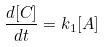<formula> <loc_0><loc_0><loc_500><loc_500>\frac { d [ C ] } { d t } = k _ { 1 } [ A ]</formula> 